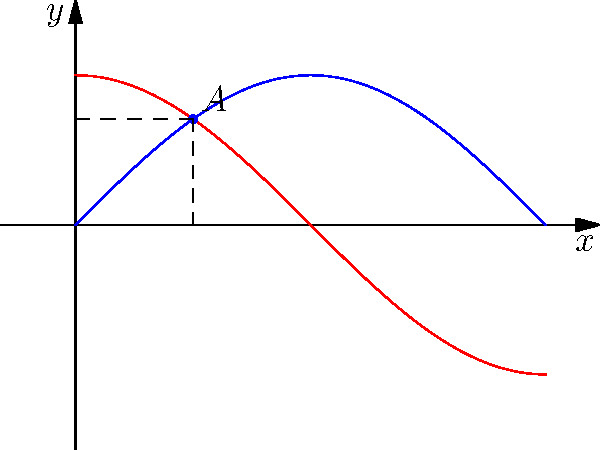As a software engineer developing a platform for global film distribution, you're working on optimizing the curvature of a dome-shaped projection surface. The curvature is modeled by the function $f(x) = \sin x$ for $0 \leq x \leq \pi$. To maximize viewer experience, you need to find the point on the curve where the tangent line forms a 45-degree angle with the x-axis. At what x-coordinate does this occur, and what is the corresponding y-coordinate of this point? Let's approach this step-by-step:

1) The slope of the tangent line at any point on $f(x) = \sin x$ is given by its derivative: $f'(x) = \cos x$.

2) We want the slope to be 1 (or 45 degrees), so:

   $\cos x = 1$

3) This occurs when $x = \frac{\pi}{4}$ (or 45 degrees).

4) To find the y-coordinate, we plug this x-value back into our original function:

   $y = \sin(\frac{\pi}{4})$

5) We know that $\sin(\frac{\pi}{4}) = \frac{\sqrt{2}}{2}$

Therefore, the point we're looking for is $(\frac{\pi}{4}, \frac{\sqrt{2}}{2})$.

This point is where the curvature of the dome-shaped projection surface will provide optimal viewing angles for the audience, balancing between the center and edge of the projection.
Answer: $(\frac{\pi}{4}, \frac{\sqrt{2}}{2})$ 